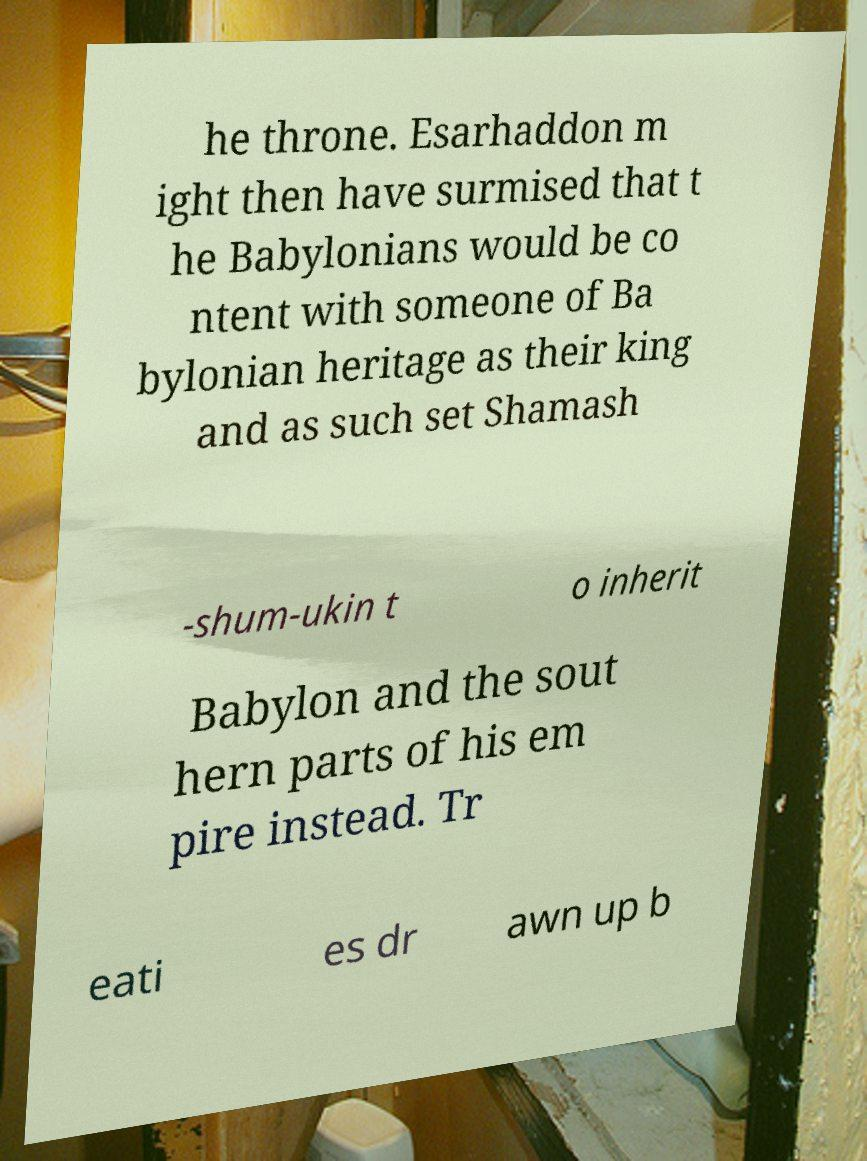What messages or text are displayed in this image? I need them in a readable, typed format. he throne. Esarhaddon m ight then have surmised that t he Babylonians would be co ntent with someone of Ba bylonian heritage as their king and as such set Shamash -shum-ukin t o inherit Babylon and the sout hern parts of his em pire instead. Tr eati es dr awn up b 